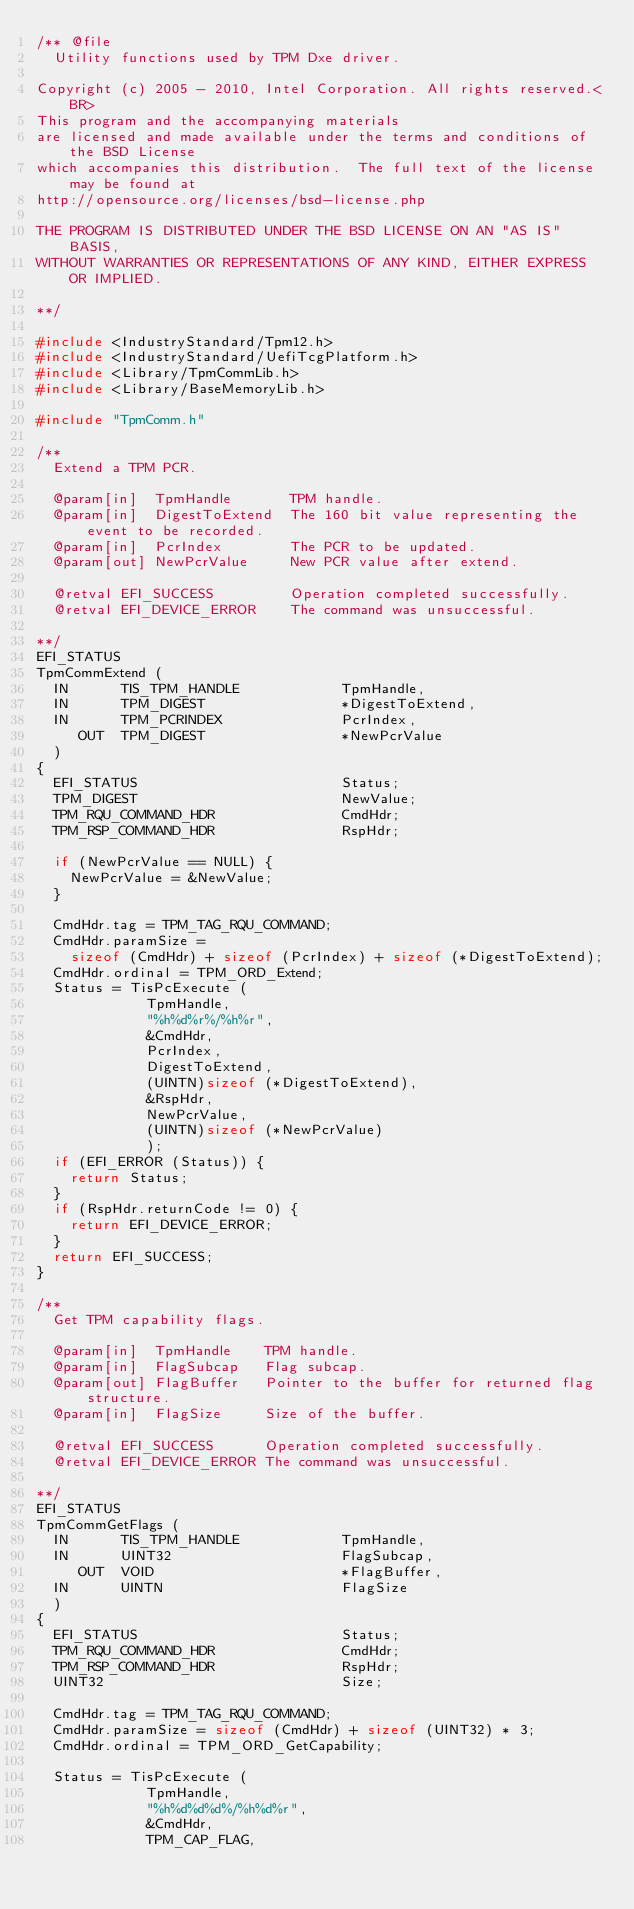<code> <loc_0><loc_0><loc_500><loc_500><_C_>/** @file  
  Utility functions used by TPM Dxe driver.

Copyright (c) 2005 - 2010, Intel Corporation. All rights reserved.<BR>
This program and the accompanying materials 
are licensed and made available under the terms and conditions of the BSD License 
which accompanies this distribution.  The full text of the license may be found at 
http://opensource.org/licenses/bsd-license.php

THE PROGRAM IS DISTRIBUTED UNDER THE BSD LICENSE ON AN "AS IS" BASIS, 
WITHOUT WARRANTIES OR REPRESENTATIONS OF ANY KIND, EITHER EXPRESS OR IMPLIED.

**/

#include <IndustryStandard/Tpm12.h>
#include <IndustryStandard/UefiTcgPlatform.h>
#include <Library/TpmCommLib.h>
#include <Library/BaseMemoryLib.h>

#include "TpmComm.h"

/**
  Extend a TPM PCR.

  @param[in]  TpmHandle       TPM handle.  
  @param[in]  DigestToExtend  The 160 bit value representing the event to be recorded.  
  @param[in]  PcrIndex        The PCR to be updated.
  @param[out] NewPcrValue     New PCR value after extend.  
  
  @retval EFI_SUCCESS         Operation completed successfully.
  @retval EFI_DEVICE_ERROR    The command was unsuccessful.

**/
EFI_STATUS
TpmCommExtend (
  IN      TIS_TPM_HANDLE            TpmHandle,
  IN      TPM_DIGEST                *DigestToExtend,
  IN      TPM_PCRINDEX              PcrIndex,
     OUT  TPM_DIGEST                *NewPcrValue
  )
{
  EFI_STATUS                        Status;
  TPM_DIGEST                        NewValue;
  TPM_RQU_COMMAND_HDR               CmdHdr;
  TPM_RSP_COMMAND_HDR               RspHdr;

  if (NewPcrValue == NULL) {
    NewPcrValue = &NewValue;
  }

  CmdHdr.tag = TPM_TAG_RQU_COMMAND;
  CmdHdr.paramSize =
    sizeof (CmdHdr) + sizeof (PcrIndex) + sizeof (*DigestToExtend);
  CmdHdr.ordinal = TPM_ORD_Extend;
  Status = TisPcExecute (
             TpmHandle,
             "%h%d%r%/%h%r",
             &CmdHdr,
             PcrIndex,
             DigestToExtend,
             (UINTN)sizeof (*DigestToExtend),
             &RspHdr,
             NewPcrValue,
             (UINTN)sizeof (*NewPcrValue)
             );
  if (EFI_ERROR (Status)) {
    return Status;
  }
  if (RspHdr.returnCode != 0) {
    return EFI_DEVICE_ERROR;
  }
  return EFI_SUCCESS;
}

/**
  Get TPM capability flags.

  @param[in]  TpmHandle    TPM handle.  
  @param[in]  FlagSubcap   Flag subcap.  
  @param[out] FlagBuffer   Pointer to the buffer for returned flag structure.
  @param[in]  FlagSize     Size of the buffer.  
  
  @retval EFI_SUCCESS      Operation completed successfully.
  @retval EFI_DEVICE_ERROR The command was unsuccessful.

**/
EFI_STATUS
TpmCommGetFlags (
  IN      TIS_TPM_HANDLE            TpmHandle,
  IN      UINT32                    FlagSubcap,
     OUT  VOID                      *FlagBuffer,
  IN      UINTN                     FlagSize
  )
{
  EFI_STATUS                        Status;
  TPM_RQU_COMMAND_HDR               CmdHdr;
  TPM_RSP_COMMAND_HDR               RspHdr;
  UINT32                            Size;

  CmdHdr.tag = TPM_TAG_RQU_COMMAND;
  CmdHdr.paramSize = sizeof (CmdHdr) + sizeof (UINT32) * 3;
  CmdHdr.ordinal = TPM_ORD_GetCapability;

  Status = TisPcExecute (
             TpmHandle,
             "%h%d%d%d%/%h%d%r",
             &CmdHdr,
             TPM_CAP_FLAG,</code> 